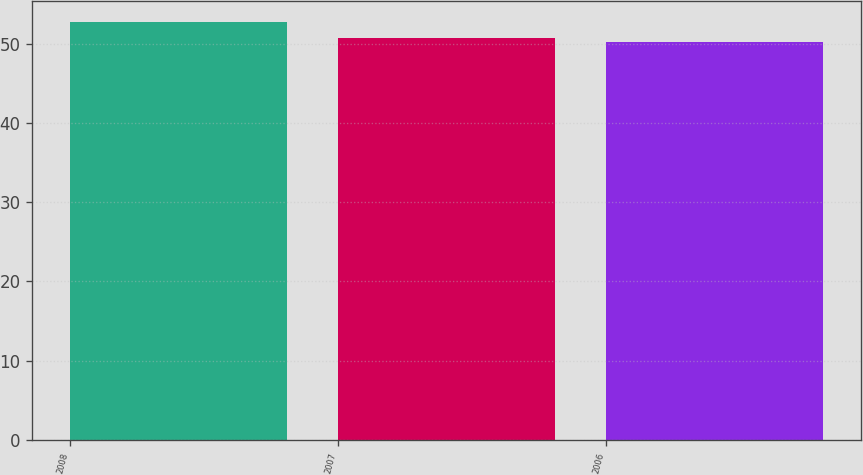Convert chart to OTSL. <chart><loc_0><loc_0><loc_500><loc_500><bar_chart><fcel>2008<fcel>2007<fcel>2006<nl><fcel>52.8<fcel>50.8<fcel>50.2<nl></chart> 